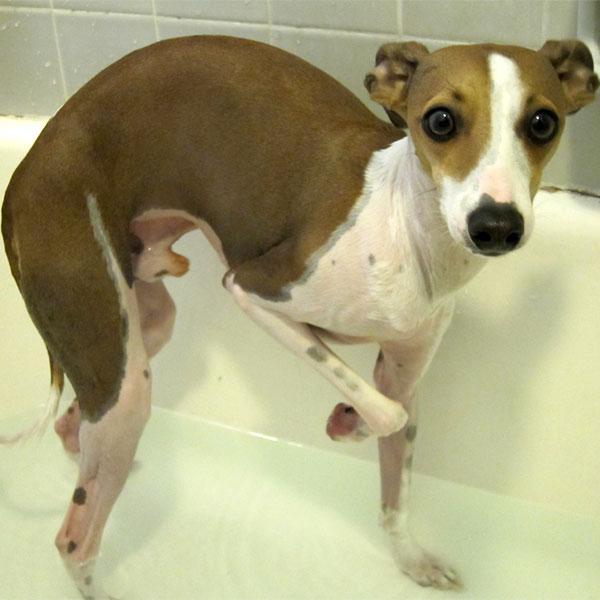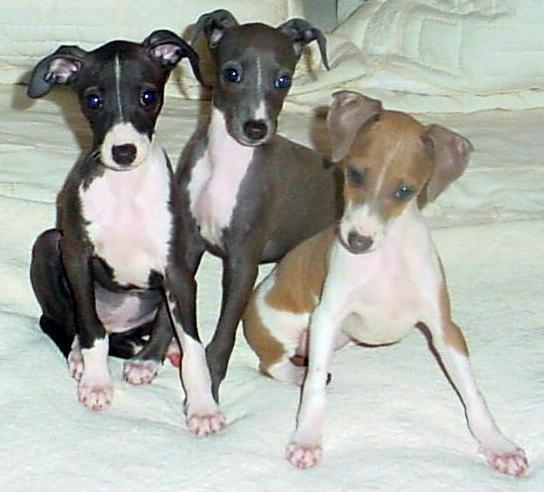The first image is the image on the left, the second image is the image on the right. For the images displayed, is the sentence "Each image contains exactly one dog, and the dog on the left is dark charcoal gray with white markings." factually correct? Answer yes or no. No. The first image is the image on the left, the second image is the image on the right. For the images displayed, is the sentence "The dog on the left is posing for the picture outside on a sunny day." factually correct? Answer yes or no. No. 